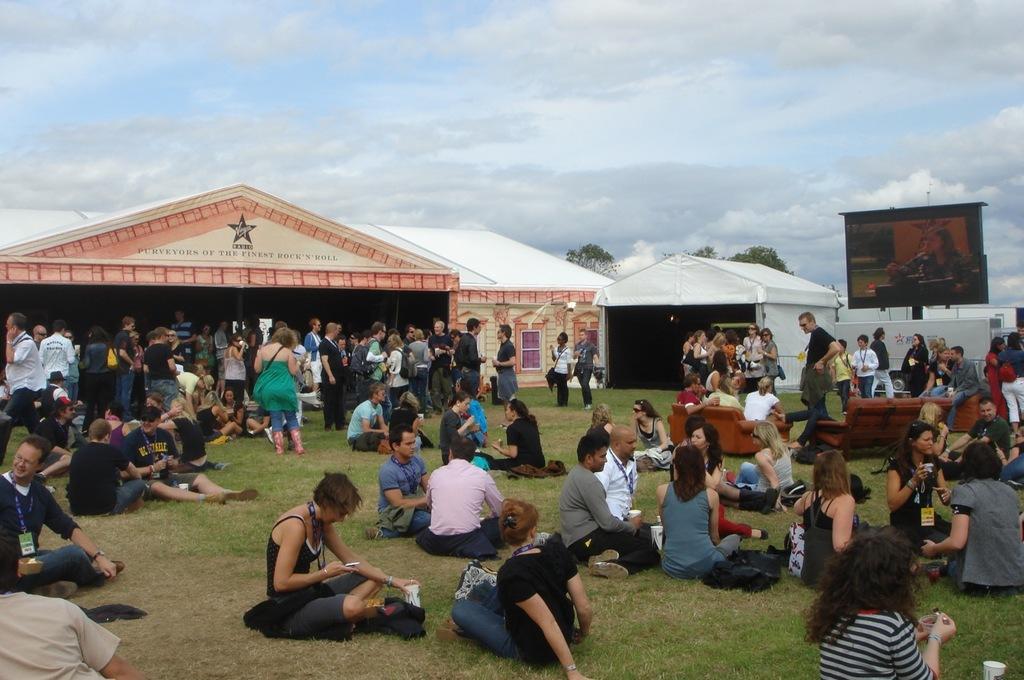Can you describe this image briefly? Sky is cloudy. Few people are sitting on grass. Here we can see sheds, screen, people and trees. These are couches. 